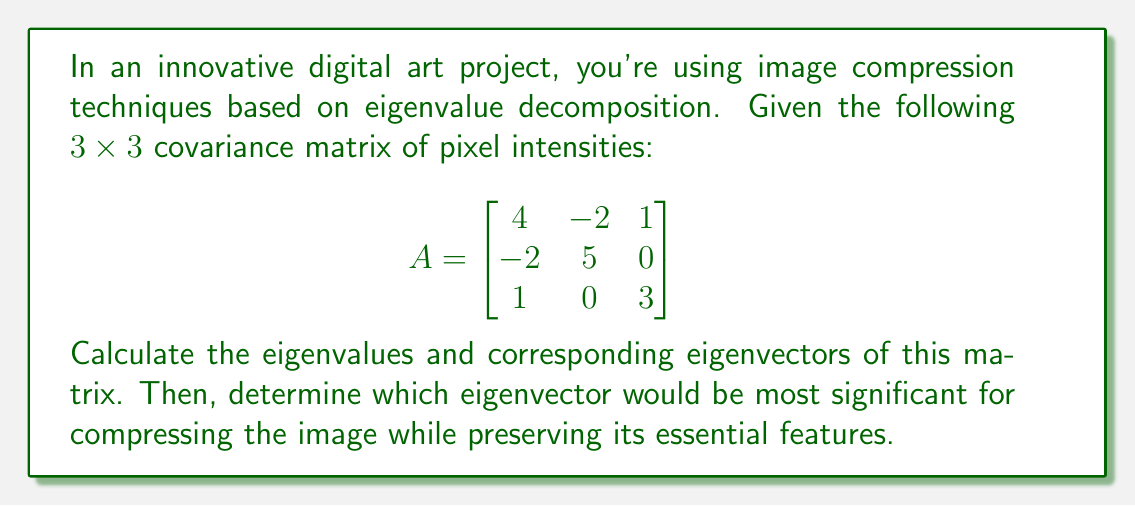What is the answer to this math problem? To find the eigenvalues and eigenvectors of matrix $A$, we follow these steps:

1) Find the characteristic equation:
   $det(A - \lambda I) = 0$

   $$\begin{vmatrix}
   4-\lambda & -2 & 1 \\
   -2 & 5-\lambda & 0 \\
   1 & 0 & 3-\lambda
   \end{vmatrix} = 0$$

2) Expand the determinant:
   $(4-\lambda)(5-\lambda)(3-\lambda) + (-2)(0)(1) + (-2)(1)(0) - (1)(5-\lambda)(1) - (4-\lambda)(0)(0) - (-2)(-2)(3-\lambda) = 0$

   $(4-\lambda)(5-\lambda)(3-\lambda) - (5-\lambda) - 4(3-\lambda) = 0$

3) Simplify:
   $\lambda^3 - 12\lambda^2 + 41\lambda - 40 = 0$

4) Solve for $\lambda$. The roots are the eigenvalues:
   $\lambda_1 = 2$, $\lambda_2 = 5$, $\lambda_3 = 5$

5) For each eigenvalue, solve $(A - \lambda I)\vec{v} = \vec{0}$ to find the corresponding eigenvector:

   For $\lambda_1 = 2$:
   $$\begin{bmatrix}
   2 & -2 & 1 \\
   -2 & 3 & 0 \\
   1 & 0 & 1
   \end{bmatrix}\begin{bmatrix}
   v_1 \\
   v_2 \\
   v_3
   \end{bmatrix} = \begin{bmatrix}
   0 \\
   0 \\
   0
   \end{bmatrix}$$

   Solving this gives: $\vec{v}_1 = \begin{bmatrix} 1 \\ 1 \\ -1 \end{bmatrix}$

   For $\lambda_2 = \lambda_3 = 5$:
   $$\begin{bmatrix}
   -1 & -2 & 1 \\
   -2 & 0 & 0 \\
   1 & 0 & -2
   \end{bmatrix}\begin{bmatrix}
   v_1 \\
   v_2 \\
   v_3
   \end{bmatrix} = \begin{bmatrix}
   0 \\
   0 \\
   0
   \end{bmatrix}$$

   Solving this gives two linearly independent eigenvectors:
   $\vec{v}_2 = \begin{bmatrix} 0 \\ 1 \\ 0 \end{bmatrix}$ and $\vec{v}_3 = \begin{bmatrix} 2 \\ 0 \\ 1 \end{bmatrix}$

6) The eigenvector corresponding to the largest eigenvalue (5) would be most significant for compressing the image while preserving its essential features. In this case, we have two eigenvectors for $\lambda = 5$. Either could be used, but typically we choose the one with the largest magnitude. Here, that's $\vec{v}_3 = \begin{bmatrix} 2 \\ 0 \\ 1 \end{bmatrix}$.
Answer: Eigenvalues: $\lambda_1 = 2$, $\lambda_2 = \lambda_3 = 5$
Eigenvectors: $\vec{v}_1 = \begin{bmatrix} 1 \\ 1 \\ -1 \end{bmatrix}$, $\vec{v}_2 = \begin{bmatrix} 0 \\ 1 \\ 0 \end{bmatrix}$, $\vec{v}_3 = \begin{bmatrix} 2 \\ 0 \\ 1 \end{bmatrix}$
Most significant eigenvector for compression: $\vec{v}_3 = \begin{bmatrix} 2 \\ 0 \\ 1 \end{bmatrix}$ 